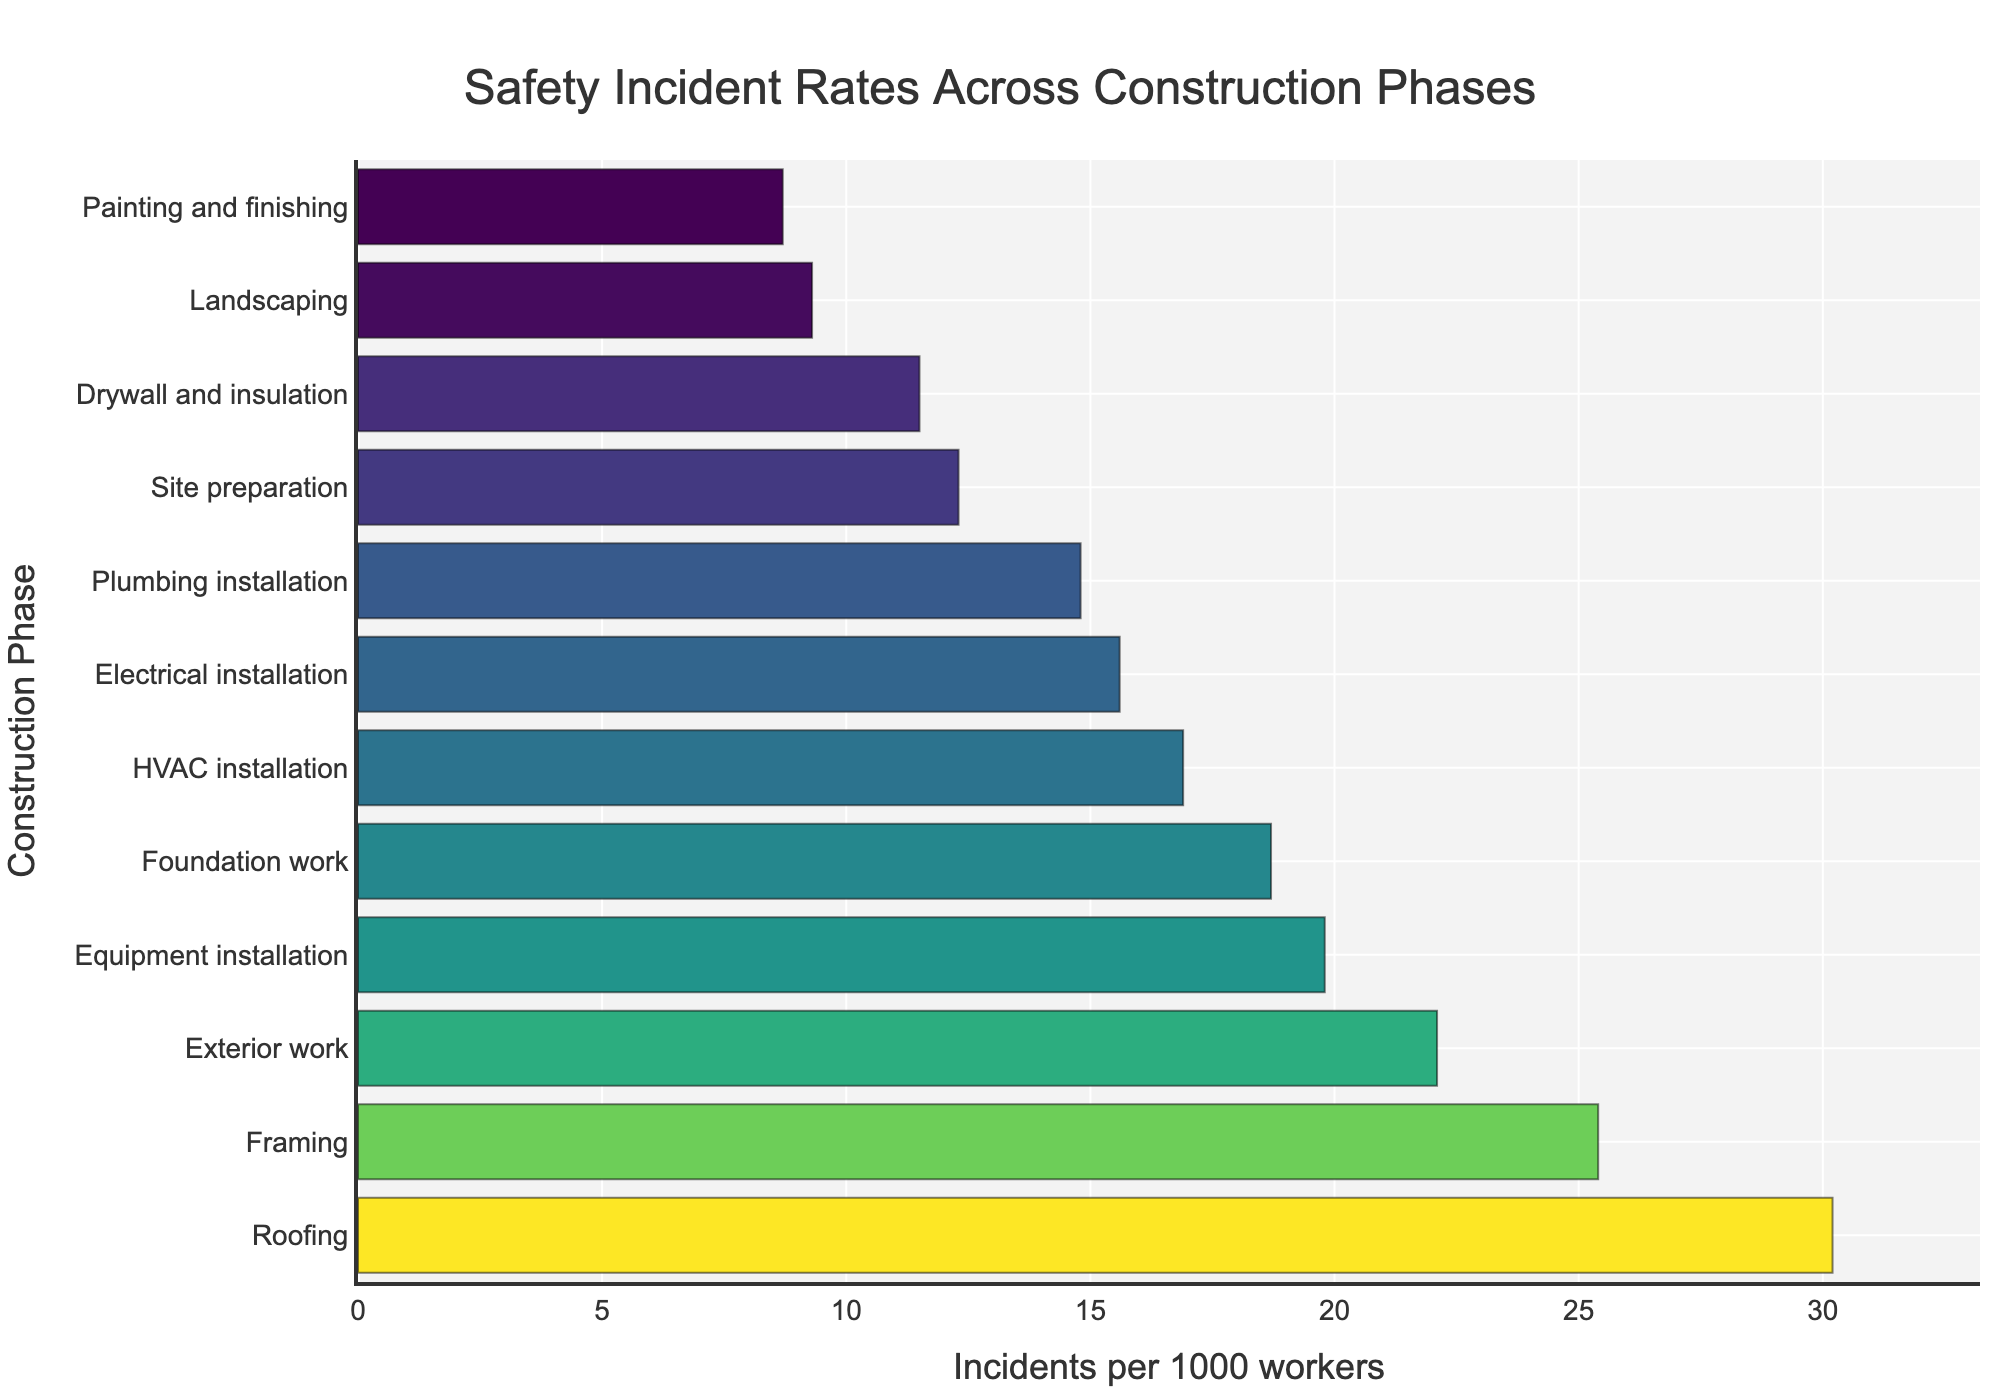Which construction phase has the highest incident rate? The bar with the greatest length corresponds to Roofing, which has the highest incident rate when sorted in descending order.
Answer: Roofing What is the incident rate for Foundation work? Locate the bar labeled "Foundation work" and note the height which represents the incident rate. The incident rate is labeled as 18.7 incidents per 1000 workers.
Answer: 18.7 Which phase has fewer incidents per 1000 workers, Electrical installation or Plumbing installation? Compare the bars labeled "Electrical installation" and "Plumbing installation." The height of the "Plumbing installation" bar is lower at 14.8 compared to Electrical installation at 15.6.
Answer: Plumbing installation What is the difference in incident rates between Framing and Exterior work? Subtract the incident rate of Exterior work (22.1) from that of Framing (25.4): 25.4 - 22.1 = 3.3
Answer: 3.3 How many phases have an incident rate higher than 20 incidents per 1000 workers? Count the bars longer than the 20-incident mark. Roofing, Framing, Exterior work, and Equipment installation have rates above 20.
Answer: 4 What is the average incident rate for Painting and finishing, Landscaping, and Drywall and insulation? Sum the incident rates of these three phases (8.7 + 9.3 + 11.5) and divide by 3. The calculation is (8.7 + 9.3 + 11.5) / 3 = 29.5 / 3 = 9.83.
Answer: 9.83 Which phase shows the smallest incident rate, and what is the rate? The shortest bar on the chart represents Painting and finishing, with an incident rate of 8.7.
Answer: Painting and finishing, 8.7 What are the median incident rates across all phases? (Compositional) List incident rates, then find the middle value: 8.7, 9.3, 11.5, 12.3, 14.8, 15.6, 16.9, 18.7, 19.8, 22.1, 25.4, 30.2. (14.8 + 15.6)/2 = 15.2 because there are 12 items, and the median is the average of the 6th and 7th items.
Answer: 15.2 